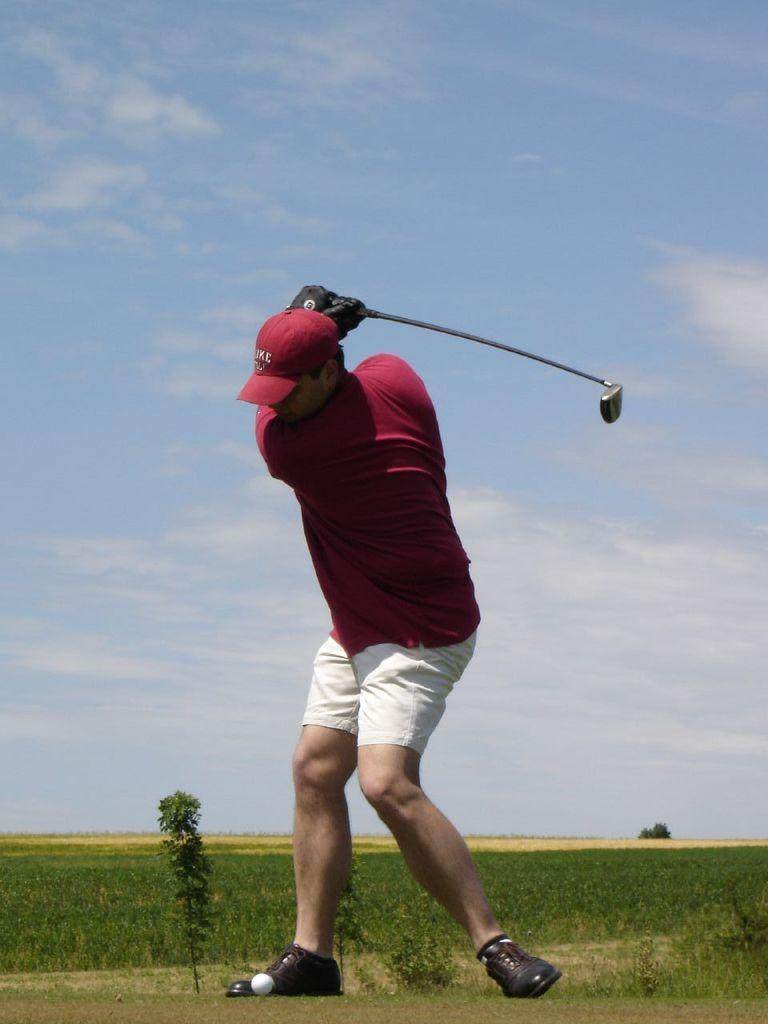Who is the main subject in the image? There is a man in the center of the image. What is the man doing in the image? The man is hitting a ball. What can be seen in the background of the image? There are plants in the background of the image. What type of ground is visible in the image? There is grass on the ground in the image. How would you describe the weather based on the image? The sky is cloudy in the image, suggesting overcast or potentially rainy weather. What month is it in the image? The month cannot be determined from the image, as there is no information about the date or season. How many mice are visible in the image? There are no mice present in the image. 